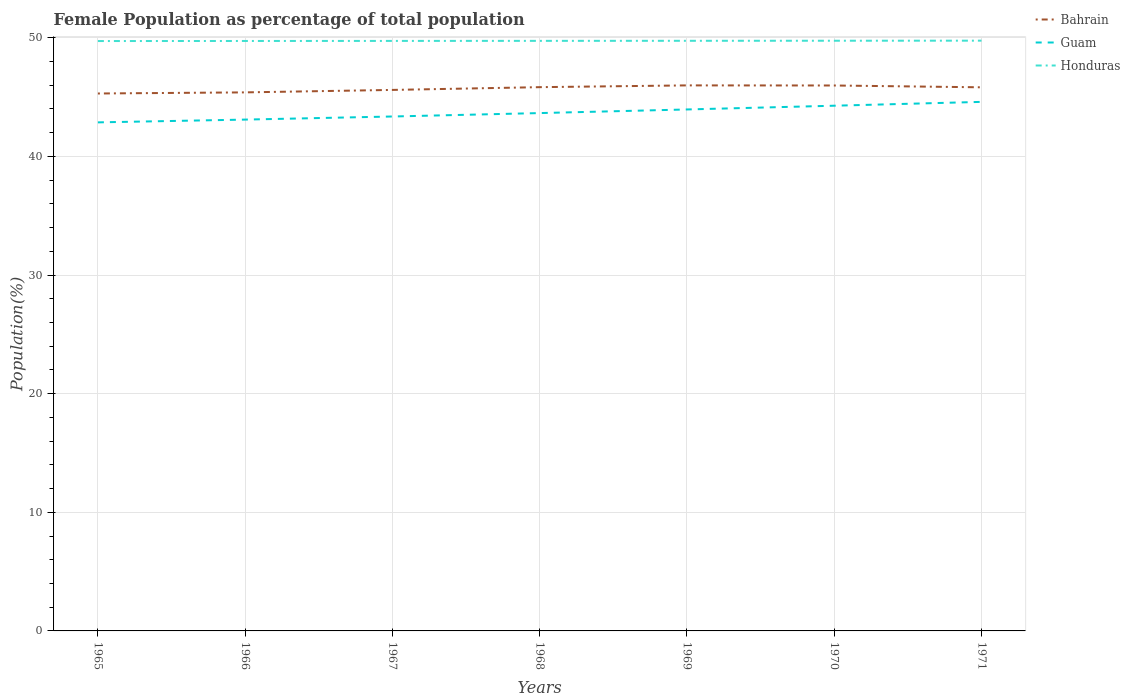Does the line corresponding to Honduras intersect with the line corresponding to Bahrain?
Your response must be concise. No. Is the number of lines equal to the number of legend labels?
Your answer should be compact. Yes. Across all years, what is the maximum female population in in Bahrain?
Your answer should be compact. 45.3. In which year was the female population in in Honduras maximum?
Your answer should be very brief. 1965. What is the total female population in in Guam in the graph?
Give a very brief answer. -1.23. What is the difference between the highest and the second highest female population in in Bahrain?
Give a very brief answer. 0.68. Is the female population in in Bahrain strictly greater than the female population in in Honduras over the years?
Your response must be concise. Yes. How many lines are there?
Your response must be concise. 3. How many years are there in the graph?
Provide a short and direct response. 7. What is the difference between two consecutive major ticks on the Y-axis?
Provide a succinct answer. 10. Does the graph contain any zero values?
Give a very brief answer. No. Does the graph contain grids?
Your answer should be compact. Yes. What is the title of the graph?
Provide a succinct answer. Female Population as percentage of total population. Does "Morocco" appear as one of the legend labels in the graph?
Give a very brief answer. No. What is the label or title of the Y-axis?
Keep it short and to the point. Population(%). What is the Population(%) in Bahrain in 1965?
Your response must be concise. 45.3. What is the Population(%) in Guam in 1965?
Make the answer very short. 42.87. What is the Population(%) in Honduras in 1965?
Offer a terse response. 49.73. What is the Population(%) of Bahrain in 1966?
Your response must be concise. 45.4. What is the Population(%) of Guam in 1966?
Your response must be concise. 43.1. What is the Population(%) in Honduras in 1966?
Offer a terse response. 49.73. What is the Population(%) in Bahrain in 1967?
Make the answer very short. 45.6. What is the Population(%) of Guam in 1967?
Your response must be concise. 43.36. What is the Population(%) in Honduras in 1967?
Give a very brief answer. 49.74. What is the Population(%) in Bahrain in 1968?
Keep it short and to the point. 45.84. What is the Population(%) of Guam in 1968?
Your answer should be very brief. 43.65. What is the Population(%) of Honduras in 1968?
Your answer should be very brief. 49.74. What is the Population(%) of Bahrain in 1969?
Provide a short and direct response. 45.99. What is the Population(%) in Guam in 1969?
Your response must be concise. 43.96. What is the Population(%) of Honduras in 1969?
Provide a succinct answer. 49.75. What is the Population(%) in Bahrain in 1970?
Keep it short and to the point. 45.98. What is the Population(%) in Guam in 1970?
Your answer should be compact. 44.27. What is the Population(%) of Honduras in 1970?
Your answer should be compact. 49.75. What is the Population(%) in Bahrain in 1971?
Your response must be concise. 45.82. What is the Population(%) of Guam in 1971?
Ensure brevity in your answer.  44.6. What is the Population(%) of Honduras in 1971?
Keep it short and to the point. 49.76. Across all years, what is the maximum Population(%) of Bahrain?
Provide a succinct answer. 45.99. Across all years, what is the maximum Population(%) of Guam?
Offer a terse response. 44.6. Across all years, what is the maximum Population(%) in Honduras?
Your response must be concise. 49.76. Across all years, what is the minimum Population(%) in Bahrain?
Offer a very short reply. 45.3. Across all years, what is the minimum Population(%) in Guam?
Your answer should be very brief. 42.87. Across all years, what is the minimum Population(%) in Honduras?
Keep it short and to the point. 49.73. What is the total Population(%) of Bahrain in the graph?
Provide a succinct answer. 319.93. What is the total Population(%) of Guam in the graph?
Ensure brevity in your answer.  305.82. What is the total Population(%) of Honduras in the graph?
Give a very brief answer. 348.19. What is the difference between the Population(%) of Bahrain in 1965 and that in 1966?
Your answer should be compact. -0.09. What is the difference between the Population(%) of Guam in 1965 and that in 1966?
Ensure brevity in your answer.  -0.23. What is the difference between the Population(%) in Honduras in 1965 and that in 1966?
Make the answer very short. -0.01. What is the difference between the Population(%) in Bahrain in 1965 and that in 1967?
Offer a very short reply. -0.3. What is the difference between the Population(%) of Guam in 1965 and that in 1967?
Your response must be concise. -0.5. What is the difference between the Population(%) of Honduras in 1965 and that in 1967?
Your answer should be very brief. -0.01. What is the difference between the Population(%) in Bahrain in 1965 and that in 1968?
Keep it short and to the point. -0.53. What is the difference between the Population(%) of Guam in 1965 and that in 1968?
Ensure brevity in your answer.  -0.78. What is the difference between the Population(%) of Honduras in 1965 and that in 1968?
Offer a very short reply. -0.02. What is the difference between the Population(%) in Bahrain in 1965 and that in 1969?
Provide a succinct answer. -0.68. What is the difference between the Population(%) of Guam in 1965 and that in 1969?
Ensure brevity in your answer.  -1.09. What is the difference between the Population(%) of Honduras in 1965 and that in 1969?
Give a very brief answer. -0.02. What is the difference between the Population(%) in Bahrain in 1965 and that in 1970?
Offer a terse response. -0.68. What is the difference between the Population(%) of Guam in 1965 and that in 1970?
Keep it short and to the point. -1.4. What is the difference between the Population(%) of Honduras in 1965 and that in 1970?
Make the answer very short. -0.03. What is the difference between the Population(%) of Bahrain in 1965 and that in 1971?
Your response must be concise. -0.52. What is the difference between the Population(%) in Guam in 1965 and that in 1971?
Ensure brevity in your answer.  -1.73. What is the difference between the Population(%) of Honduras in 1965 and that in 1971?
Give a very brief answer. -0.03. What is the difference between the Population(%) in Bahrain in 1966 and that in 1967?
Ensure brevity in your answer.  -0.21. What is the difference between the Population(%) in Guam in 1966 and that in 1967?
Give a very brief answer. -0.26. What is the difference between the Population(%) of Honduras in 1966 and that in 1967?
Provide a succinct answer. -0.01. What is the difference between the Population(%) in Bahrain in 1966 and that in 1968?
Offer a very short reply. -0.44. What is the difference between the Population(%) of Guam in 1966 and that in 1968?
Offer a very short reply. -0.55. What is the difference between the Population(%) in Honduras in 1966 and that in 1968?
Offer a terse response. -0.01. What is the difference between the Population(%) of Bahrain in 1966 and that in 1969?
Your response must be concise. -0.59. What is the difference between the Population(%) of Guam in 1966 and that in 1969?
Your answer should be compact. -0.85. What is the difference between the Population(%) in Honduras in 1966 and that in 1969?
Ensure brevity in your answer.  -0.02. What is the difference between the Population(%) of Bahrain in 1966 and that in 1970?
Provide a short and direct response. -0.58. What is the difference between the Population(%) of Guam in 1966 and that in 1970?
Make the answer very short. -1.17. What is the difference between the Population(%) in Honduras in 1966 and that in 1970?
Your answer should be compact. -0.02. What is the difference between the Population(%) of Bahrain in 1966 and that in 1971?
Keep it short and to the point. -0.43. What is the difference between the Population(%) of Guam in 1966 and that in 1971?
Your answer should be compact. -1.49. What is the difference between the Population(%) of Honduras in 1966 and that in 1971?
Make the answer very short. -0.03. What is the difference between the Population(%) of Bahrain in 1967 and that in 1968?
Keep it short and to the point. -0.23. What is the difference between the Population(%) of Guam in 1967 and that in 1968?
Provide a short and direct response. -0.29. What is the difference between the Population(%) of Honduras in 1967 and that in 1968?
Ensure brevity in your answer.  -0. What is the difference between the Population(%) of Bahrain in 1967 and that in 1969?
Your answer should be compact. -0.38. What is the difference between the Population(%) in Guam in 1967 and that in 1969?
Provide a succinct answer. -0.59. What is the difference between the Population(%) in Honduras in 1967 and that in 1969?
Offer a terse response. -0.01. What is the difference between the Population(%) in Bahrain in 1967 and that in 1970?
Make the answer very short. -0.37. What is the difference between the Population(%) in Guam in 1967 and that in 1970?
Offer a very short reply. -0.91. What is the difference between the Population(%) in Honduras in 1967 and that in 1970?
Give a very brief answer. -0.02. What is the difference between the Population(%) of Bahrain in 1967 and that in 1971?
Your response must be concise. -0.22. What is the difference between the Population(%) in Guam in 1967 and that in 1971?
Provide a short and direct response. -1.23. What is the difference between the Population(%) in Honduras in 1967 and that in 1971?
Offer a very short reply. -0.02. What is the difference between the Population(%) of Bahrain in 1968 and that in 1969?
Provide a short and direct response. -0.15. What is the difference between the Population(%) of Guam in 1968 and that in 1969?
Keep it short and to the point. -0.3. What is the difference between the Population(%) of Honduras in 1968 and that in 1969?
Offer a terse response. -0. What is the difference between the Population(%) in Bahrain in 1968 and that in 1970?
Your answer should be very brief. -0.14. What is the difference between the Population(%) in Guam in 1968 and that in 1970?
Make the answer very short. -0.62. What is the difference between the Population(%) of Honduras in 1968 and that in 1970?
Ensure brevity in your answer.  -0.01. What is the difference between the Population(%) in Bahrain in 1968 and that in 1971?
Ensure brevity in your answer.  0.01. What is the difference between the Population(%) of Guam in 1968 and that in 1971?
Provide a short and direct response. -0.94. What is the difference between the Population(%) in Honduras in 1968 and that in 1971?
Your answer should be compact. -0.02. What is the difference between the Population(%) of Bahrain in 1969 and that in 1970?
Your answer should be compact. 0.01. What is the difference between the Population(%) of Guam in 1969 and that in 1970?
Give a very brief answer. -0.32. What is the difference between the Population(%) of Honduras in 1969 and that in 1970?
Offer a very short reply. -0.01. What is the difference between the Population(%) of Bahrain in 1969 and that in 1971?
Make the answer very short. 0.16. What is the difference between the Population(%) in Guam in 1969 and that in 1971?
Your answer should be very brief. -0.64. What is the difference between the Population(%) of Honduras in 1969 and that in 1971?
Offer a terse response. -0.01. What is the difference between the Population(%) in Bahrain in 1970 and that in 1971?
Offer a very short reply. 0.15. What is the difference between the Population(%) of Guam in 1970 and that in 1971?
Your response must be concise. -0.32. What is the difference between the Population(%) of Honduras in 1970 and that in 1971?
Give a very brief answer. -0.01. What is the difference between the Population(%) in Bahrain in 1965 and the Population(%) in Guam in 1966?
Make the answer very short. 2.2. What is the difference between the Population(%) in Bahrain in 1965 and the Population(%) in Honduras in 1966?
Offer a very short reply. -4.43. What is the difference between the Population(%) of Guam in 1965 and the Population(%) of Honduras in 1966?
Make the answer very short. -6.86. What is the difference between the Population(%) of Bahrain in 1965 and the Population(%) of Guam in 1967?
Give a very brief answer. 1.94. What is the difference between the Population(%) of Bahrain in 1965 and the Population(%) of Honduras in 1967?
Your answer should be very brief. -4.43. What is the difference between the Population(%) of Guam in 1965 and the Population(%) of Honduras in 1967?
Provide a succinct answer. -6.87. What is the difference between the Population(%) of Bahrain in 1965 and the Population(%) of Guam in 1968?
Provide a succinct answer. 1.65. What is the difference between the Population(%) of Bahrain in 1965 and the Population(%) of Honduras in 1968?
Offer a terse response. -4.44. What is the difference between the Population(%) in Guam in 1965 and the Population(%) in Honduras in 1968?
Keep it short and to the point. -6.87. What is the difference between the Population(%) in Bahrain in 1965 and the Population(%) in Guam in 1969?
Give a very brief answer. 1.35. What is the difference between the Population(%) in Bahrain in 1965 and the Population(%) in Honduras in 1969?
Make the answer very short. -4.44. What is the difference between the Population(%) of Guam in 1965 and the Population(%) of Honduras in 1969?
Provide a short and direct response. -6.88. What is the difference between the Population(%) in Bahrain in 1965 and the Population(%) in Guam in 1970?
Ensure brevity in your answer.  1.03. What is the difference between the Population(%) in Bahrain in 1965 and the Population(%) in Honduras in 1970?
Your answer should be very brief. -4.45. What is the difference between the Population(%) in Guam in 1965 and the Population(%) in Honduras in 1970?
Make the answer very short. -6.88. What is the difference between the Population(%) of Bahrain in 1965 and the Population(%) of Guam in 1971?
Provide a succinct answer. 0.71. What is the difference between the Population(%) in Bahrain in 1965 and the Population(%) in Honduras in 1971?
Provide a short and direct response. -4.45. What is the difference between the Population(%) of Guam in 1965 and the Population(%) of Honduras in 1971?
Ensure brevity in your answer.  -6.89. What is the difference between the Population(%) of Bahrain in 1966 and the Population(%) of Guam in 1967?
Offer a terse response. 2.03. What is the difference between the Population(%) of Bahrain in 1966 and the Population(%) of Honduras in 1967?
Give a very brief answer. -4.34. What is the difference between the Population(%) of Guam in 1966 and the Population(%) of Honduras in 1967?
Make the answer very short. -6.63. What is the difference between the Population(%) in Bahrain in 1966 and the Population(%) in Guam in 1968?
Offer a terse response. 1.74. What is the difference between the Population(%) in Bahrain in 1966 and the Population(%) in Honduras in 1968?
Your answer should be very brief. -4.34. What is the difference between the Population(%) of Guam in 1966 and the Population(%) of Honduras in 1968?
Keep it short and to the point. -6.64. What is the difference between the Population(%) in Bahrain in 1966 and the Population(%) in Guam in 1969?
Your answer should be compact. 1.44. What is the difference between the Population(%) of Bahrain in 1966 and the Population(%) of Honduras in 1969?
Give a very brief answer. -4.35. What is the difference between the Population(%) of Guam in 1966 and the Population(%) of Honduras in 1969?
Offer a very short reply. -6.64. What is the difference between the Population(%) of Bahrain in 1966 and the Population(%) of Guam in 1970?
Provide a succinct answer. 1.12. What is the difference between the Population(%) in Bahrain in 1966 and the Population(%) in Honduras in 1970?
Offer a terse response. -4.35. What is the difference between the Population(%) in Guam in 1966 and the Population(%) in Honduras in 1970?
Keep it short and to the point. -6.65. What is the difference between the Population(%) in Bahrain in 1966 and the Population(%) in Guam in 1971?
Offer a terse response. 0.8. What is the difference between the Population(%) in Bahrain in 1966 and the Population(%) in Honduras in 1971?
Provide a succinct answer. -4.36. What is the difference between the Population(%) of Guam in 1966 and the Population(%) of Honduras in 1971?
Offer a very short reply. -6.65. What is the difference between the Population(%) of Bahrain in 1967 and the Population(%) of Guam in 1968?
Ensure brevity in your answer.  1.95. What is the difference between the Population(%) of Bahrain in 1967 and the Population(%) of Honduras in 1968?
Ensure brevity in your answer.  -4.14. What is the difference between the Population(%) in Guam in 1967 and the Population(%) in Honduras in 1968?
Offer a terse response. -6.38. What is the difference between the Population(%) of Bahrain in 1967 and the Population(%) of Guam in 1969?
Give a very brief answer. 1.65. What is the difference between the Population(%) of Bahrain in 1967 and the Population(%) of Honduras in 1969?
Give a very brief answer. -4.14. What is the difference between the Population(%) of Guam in 1967 and the Population(%) of Honduras in 1969?
Provide a succinct answer. -6.38. What is the difference between the Population(%) of Bahrain in 1967 and the Population(%) of Guam in 1970?
Your answer should be compact. 1.33. What is the difference between the Population(%) of Bahrain in 1967 and the Population(%) of Honduras in 1970?
Provide a short and direct response. -4.15. What is the difference between the Population(%) in Guam in 1967 and the Population(%) in Honduras in 1970?
Your answer should be very brief. -6.39. What is the difference between the Population(%) of Bahrain in 1967 and the Population(%) of Guam in 1971?
Give a very brief answer. 1.01. What is the difference between the Population(%) in Bahrain in 1967 and the Population(%) in Honduras in 1971?
Offer a very short reply. -4.15. What is the difference between the Population(%) of Guam in 1967 and the Population(%) of Honduras in 1971?
Keep it short and to the point. -6.39. What is the difference between the Population(%) of Bahrain in 1968 and the Population(%) of Guam in 1969?
Your response must be concise. 1.88. What is the difference between the Population(%) of Bahrain in 1968 and the Population(%) of Honduras in 1969?
Keep it short and to the point. -3.91. What is the difference between the Population(%) of Guam in 1968 and the Population(%) of Honduras in 1969?
Your answer should be compact. -6.09. What is the difference between the Population(%) of Bahrain in 1968 and the Population(%) of Guam in 1970?
Ensure brevity in your answer.  1.56. What is the difference between the Population(%) in Bahrain in 1968 and the Population(%) in Honduras in 1970?
Your answer should be compact. -3.91. What is the difference between the Population(%) of Guam in 1968 and the Population(%) of Honduras in 1970?
Make the answer very short. -6.1. What is the difference between the Population(%) of Bahrain in 1968 and the Population(%) of Guam in 1971?
Your answer should be very brief. 1.24. What is the difference between the Population(%) in Bahrain in 1968 and the Population(%) in Honduras in 1971?
Make the answer very short. -3.92. What is the difference between the Population(%) of Guam in 1968 and the Population(%) of Honduras in 1971?
Your answer should be very brief. -6.1. What is the difference between the Population(%) in Bahrain in 1969 and the Population(%) in Guam in 1970?
Offer a terse response. 1.71. What is the difference between the Population(%) in Bahrain in 1969 and the Population(%) in Honduras in 1970?
Make the answer very short. -3.76. What is the difference between the Population(%) in Guam in 1969 and the Population(%) in Honduras in 1970?
Give a very brief answer. -5.79. What is the difference between the Population(%) in Bahrain in 1969 and the Population(%) in Guam in 1971?
Your response must be concise. 1.39. What is the difference between the Population(%) in Bahrain in 1969 and the Population(%) in Honduras in 1971?
Ensure brevity in your answer.  -3.77. What is the difference between the Population(%) of Guam in 1969 and the Population(%) of Honduras in 1971?
Give a very brief answer. -5.8. What is the difference between the Population(%) in Bahrain in 1970 and the Population(%) in Guam in 1971?
Provide a short and direct response. 1.38. What is the difference between the Population(%) in Bahrain in 1970 and the Population(%) in Honduras in 1971?
Make the answer very short. -3.78. What is the difference between the Population(%) in Guam in 1970 and the Population(%) in Honduras in 1971?
Provide a short and direct response. -5.48. What is the average Population(%) of Bahrain per year?
Your response must be concise. 45.7. What is the average Population(%) of Guam per year?
Give a very brief answer. 43.69. What is the average Population(%) in Honduras per year?
Keep it short and to the point. 49.74. In the year 1965, what is the difference between the Population(%) of Bahrain and Population(%) of Guam?
Provide a succinct answer. 2.43. In the year 1965, what is the difference between the Population(%) in Bahrain and Population(%) in Honduras?
Your answer should be compact. -4.42. In the year 1965, what is the difference between the Population(%) in Guam and Population(%) in Honduras?
Offer a terse response. -6.86. In the year 1966, what is the difference between the Population(%) in Bahrain and Population(%) in Guam?
Offer a very short reply. 2.29. In the year 1966, what is the difference between the Population(%) in Bahrain and Population(%) in Honduras?
Your response must be concise. -4.33. In the year 1966, what is the difference between the Population(%) in Guam and Population(%) in Honduras?
Provide a succinct answer. -6.63. In the year 1967, what is the difference between the Population(%) in Bahrain and Population(%) in Guam?
Your answer should be very brief. 2.24. In the year 1967, what is the difference between the Population(%) of Bahrain and Population(%) of Honduras?
Your response must be concise. -4.13. In the year 1967, what is the difference between the Population(%) of Guam and Population(%) of Honduras?
Your response must be concise. -6.37. In the year 1968, what is the difference between the Population(%) in Bahrain and Population(%) in Guam?
Provide a short and direct response. 2.19. In the year 1968, what is the difference between the Population(%) in Bahrain and Population(%) in Honduras?
Offer a terse response. -3.9. In the year 1968, what is the difference between the Population(%) in Guam and Population(%) in Honduras?
Ensure brevity in your answer.  -6.09. In the year 1969, what is the difference between the Population(%) of Bahrain and Population(%) of Guam?
Provide a short and direct response. 2.03. In the year 1969, what is the difference between the Population(%) in Bahrain and Population(%) in Honduras?
Ensure brevity in your answer.  -3.76. In the year 1969, what is the difference between the Population(%) of Guam and Population(%) of Honduras?
Keep it short and to the point. -5.79. In the year 1970, what is the difference between the Population(%) in Bahrain and Population(%) in Guam?
Offer a very short reply. 1.7. In the year 1970, what is the difference between the Population(%) of Bahrain and Population(%) of Honduras?
Your answer should be very brief. -3.77. In the year 1970, what is the difference between the Population(%) of Guam and Population(%) of Honduras?
Provide a succinct answer. -5.48. In the year 1971, what is the difference between the Population(%) in Bahrain and Population(%) in Guam?
Ensure brevity in your answer.  1.23. In the year 1971, what is the difference between the Population(%) of Bahrain and Population(%) of Honduras?
Give a very brief answer. -3.93. In the year 1971, what is the difference between the Population(%) in Guam and Population(%) in Honduras?
Keep it short and to the point. -5.16. What is the ratio of the Population(%) of Honduras in 1965 to that in 1966?
Your answer should be very brief. 1. What is the ratio of the Population(%) in Bahrain in 1965 to that in 1967?
Offer a very short reply. 0.99. What is the ratio of the Population(%) of Honduras in 1965 to that in 1967?
Give a very brief answer. 1. What is the ratio of the Population(%) in Bahrain in 1965 to that in 1968?
Provide a succinct answer. 0.99. What is the ratio of the Population(%) in Guam in 1965 to that in 1968?
Keep it short and to the point. 0.98. What is the ratio of the Population(%) of Bahrain in 1965 to that in 1969?
Give a very brief answer. 0.99. What is the ratio of the Population(%) of Guam in 1965 to that in 1969?
Provide a succinct answer. 0.98. What is the ratio of the Population(%) of Honduras in 1965 to that in 1969?
Keep it short and to the point. 1. What is the ratio of the Population(%) of Guam in 1965 to that in 1970?
Ensure brevity in your answer.  0.97. What is the ratio of the Population(%) in Honduras in 1965 to that in 1970?
Provide a short and direct response. 1. What is the ratio of the Population(%) in Bahrain in 1965 to that in 1971?
Ensure brevity in your answer.  0.99. What is the ratio of the Population(%) of Guam in 1965 to that in 1971?
Your answer should be compact. 0.96. What is the ratio of the Population(%) in Honduras in 1965 to that in 1971?
Ensure brevity in your answer.  1. What is the ratio of the Population(%) of Guam in 1966 to that in 1968?
Give a very brief answer. 0.99. What is the ratio of the Population(%) of Bahrain in 1966 to that in 1969?
Your response must be concise. 0.99. What is the ratio of the Population(%) of Guam in 1966 to that in 1969?
Make the answer very short. 0.98. What is the ratio of the Population(%) in Bahrain in 1966 to that in 1970?
Ensure brevity in your answer.  0.99. What is the ratio of the Population(%) of Guam in 1966 to that in 1970?
Your response must be concise. 0.97. What is the ratio of the Population(%) of Bahrain in 1966 to that in 1971?
Ensure brevity in your answer.  0.99. What is the ratio of the Population(%) in Guam in 1966 to that in 1971?
Ensure brevity in your answer.  0.97. What is the ratio of the Population(%) in Guam in 1967 to that in 1968?
Offer a terse response. 0.99. What is the ratio of the Population(%) of Honduras in 1967 to that in 1968?
Offer a terse response. 1. What is the ratio of the Population(%) of Guam in 1967 to that in 1969?
Ensure brevity in your answer.  0.99. What is the ratio of the Population(%) in Honduras in 1967 to that in 1969?
Offer a very short reply. 1. What is the ratio of the Population(%) in Bahrain in 1967 to that in 1970?
Make the answer very short. 0.99. What is the ratio of the Population(%) in Guam in 1967 to that in 1970?
Ensure brevity in your answer.  0.98. What is the ratio of the Population(%) of Honduras in 1967 to that in 1970?
Your response must be concise. 1. What is the ratio of the Population(%) in Guam in 1967 to that in 1971?
Make the answer very short. 0.97. What is the ratio of the Population(%) in Bahrain in 1968 to that in 1969?
Provide a succinct answer. 1. What is the ratio of the Population(%) of Honduras in 1968 to that in 1969?
Your answer should be compact. 1. What is the ratio of the Population(%) of Honduras in 1968 to that in 1970?
Ensure brevity in your answer.  1. What is the ratio of the Population(%) in Guam in 1968 to that in 1971?
Ensure brevity in your answer.  0.98. What is the ratio of the Population(%) in Bahrain in 1969 to that in 1970?
Keep it short and to the point. 1. What is the ratio of the Population(%) of Guam in 1969 to that in 1970?
Offer a very short reply. 0.99. What is the ratio of the Population(%) of Guam in 1969 to that in 1971?
Make the answer very short. 0.99. What is the ratio of the Population(%) in Bahrain in 1970 to that in 1971?
Your answer should be very brief. 1. What is the difference between the highest and the second highest Population(%) of Bahrain?
Your answer should be compact. 0.01. What is the difference between the highest and the second highest Population(%) of Guam?
Ensure brevity in your answer.  0.32. What is the difference between the highest and the second highest Population(%) of Honduras?
Offer a terse response. 0.01. What is the difference between the highest and the lowest Population(%) in Bahrain?
Your answer should be compact. 0.68. What is the difference between the highest and the lowest Population(%) of Guam?
Your response must be concise. 1.73. What is the difference between the highest and the lowest Population(%) of Honduras?
Ensure brevity in your answer.  0.03. 